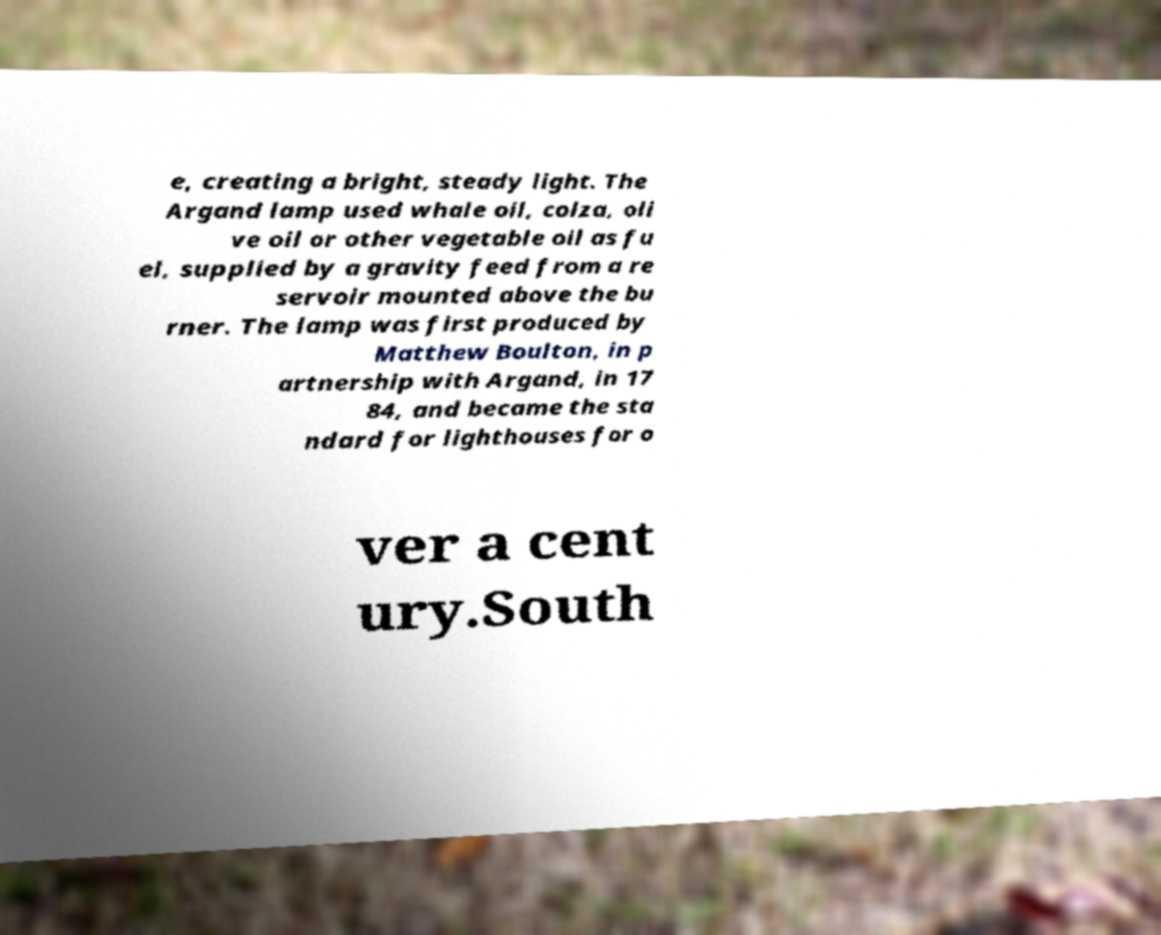Can you read and provide the text displayed in the image?This photo seems to have some interesting text. Can you extract and type it out for me? e, creating a bright, steady light. The Argand lamp used whale oil, colza, oli ve oil or other vegetable oil as fu el, supplied by a gravity feed from a re servoir mounted above the bu rner. The lamp was first produced by Matthew Boulton, in p artnership with Argand, in 17 84, and became the sta ndard for lighthouses for o ver a cent ury.South 